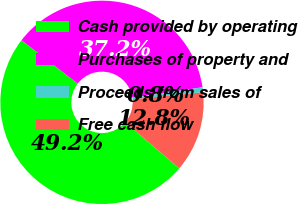Convert chart. <chart><loc_0><loc_0><loc_500><loc_500><pie_chart><fcel>Cash provided by operating<fcel>Purchases of property and<fcel>Proceeds from sales of<fcel>Free cash flow<nl><fcel>49.21%<fcel>37.17%<fcel>0.79%<fcel>12.83%<nl></chart> 